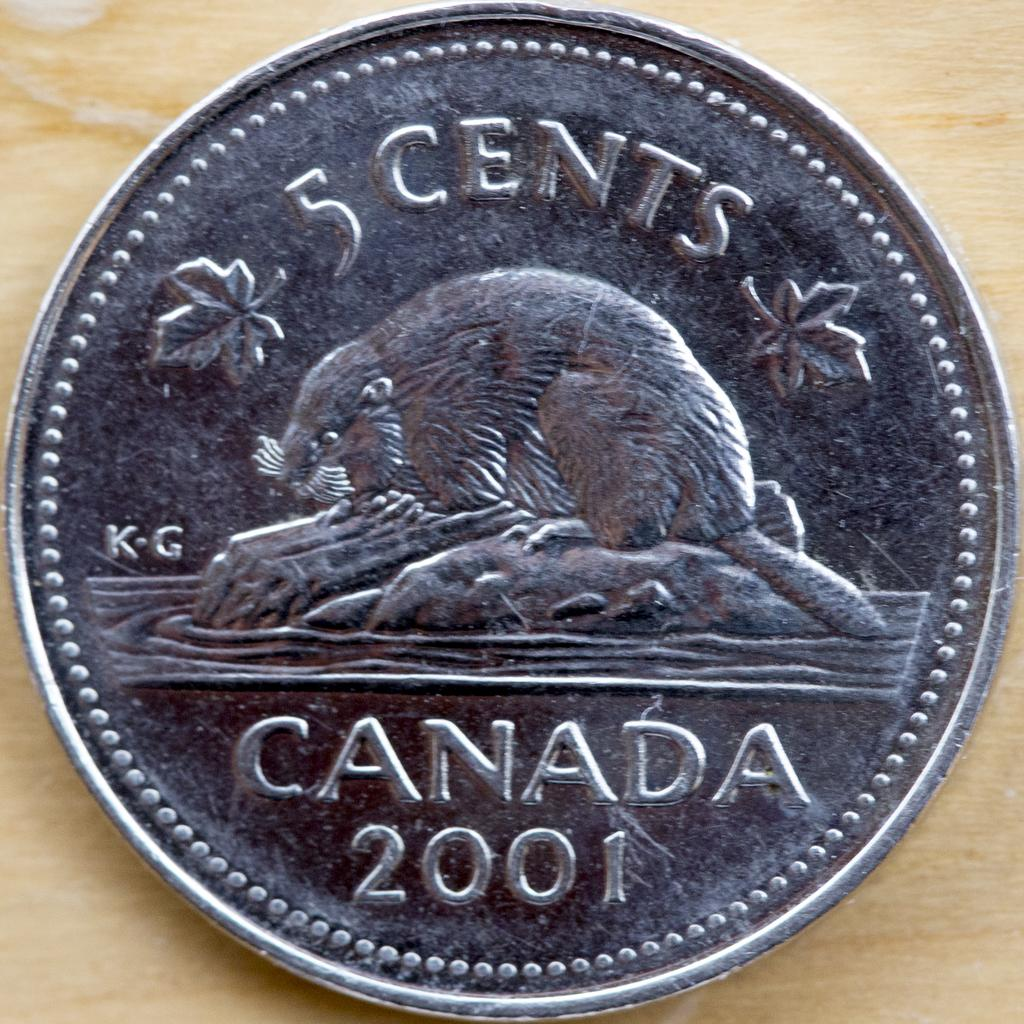What object is in the image? There is a coin in the image. How much is the coin worth? The coin is worth 5 cents. Where is the coin located? The coin is on a table. What type of body is being treated at the hospital in the image? There is no hospital or body present in the image; it only features a coin on a table. 